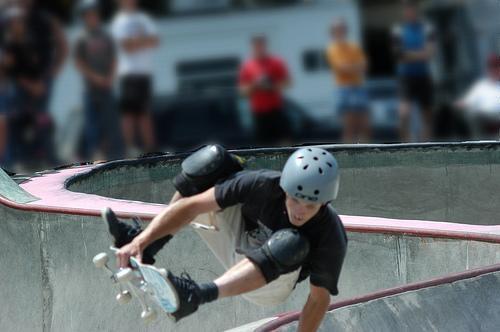How many people are playing football?
Give a very brief answer. 0. 